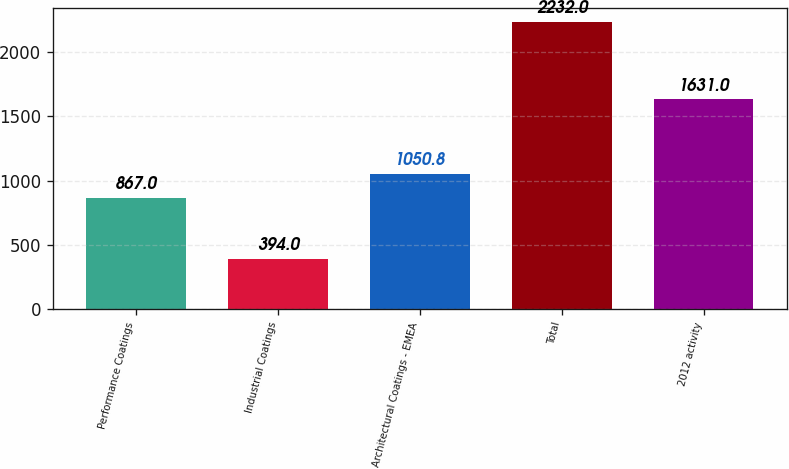Convert chart to OTSL. <chart><loc_0><loc_0><loc_500><loc_500><bar_chart><fcel>Performance Coatings<fcel>Industrial Coatings<fcel>Architectural Coatings - EMEA<fcel>Total<fcel>2012 activity<nl><fcel>867<fcel>394<fcel>1050.8<fcel>2232<fcel>1631<nl></chart> 